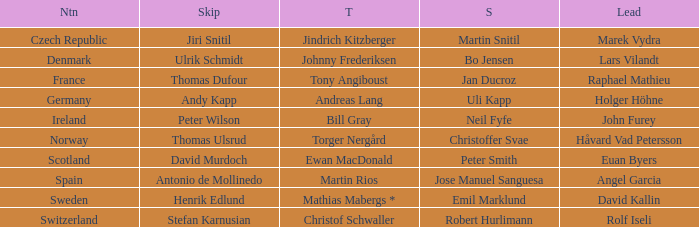In which one-third portion was angel garcia the leader? Martin Rios. 